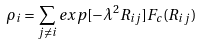Convert formula to latex. <formula><loc_0><loc_0><loc_500><loc_500>\rho _ { i } = \sum _ { j \neq i } e x p [ - \lambda ^ { 2 } R _ { i j } ] F _ { c } ( R _ { i j } )</formula> 